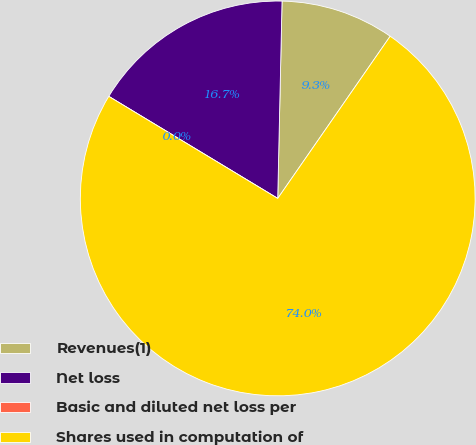Convert chart. <chart><loc_0><loc_0><loc_500><loc_500><pie_chart><fcel>Revenues(1)<fcel>Net loss<fcel>Basic and diluted net loss per<fcel>Shares used in computation of<nl><fcel>9.3%<fcel>16.7%<fcel>0.0%<fcel>74.0%<nl></chart> 